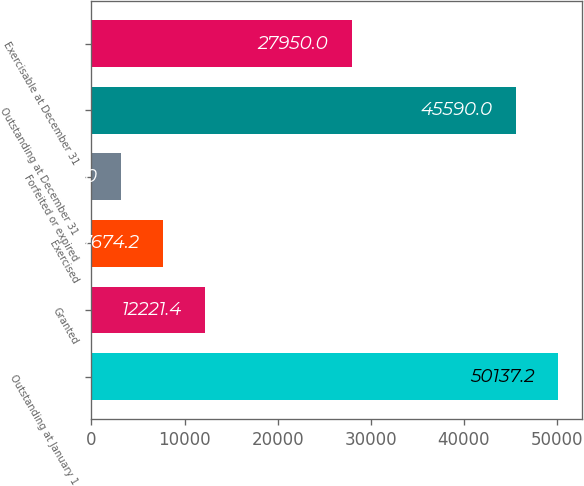Convert chart. <chart><loc_0><loc_0><loc_500><loc_500><bar_chart><fcel>Outstanding at January 1<fcel>Granted<fcel>Exercised<fcel>Forfeited or expired<fcel>Outstanding at December 31<fcel>Exercisable at December 31<nl><fcel>50137.2<fcel>12221.4<fcel>7674.2<fcel>3127<fcel>45590<fcel>27950<nl></chart> 